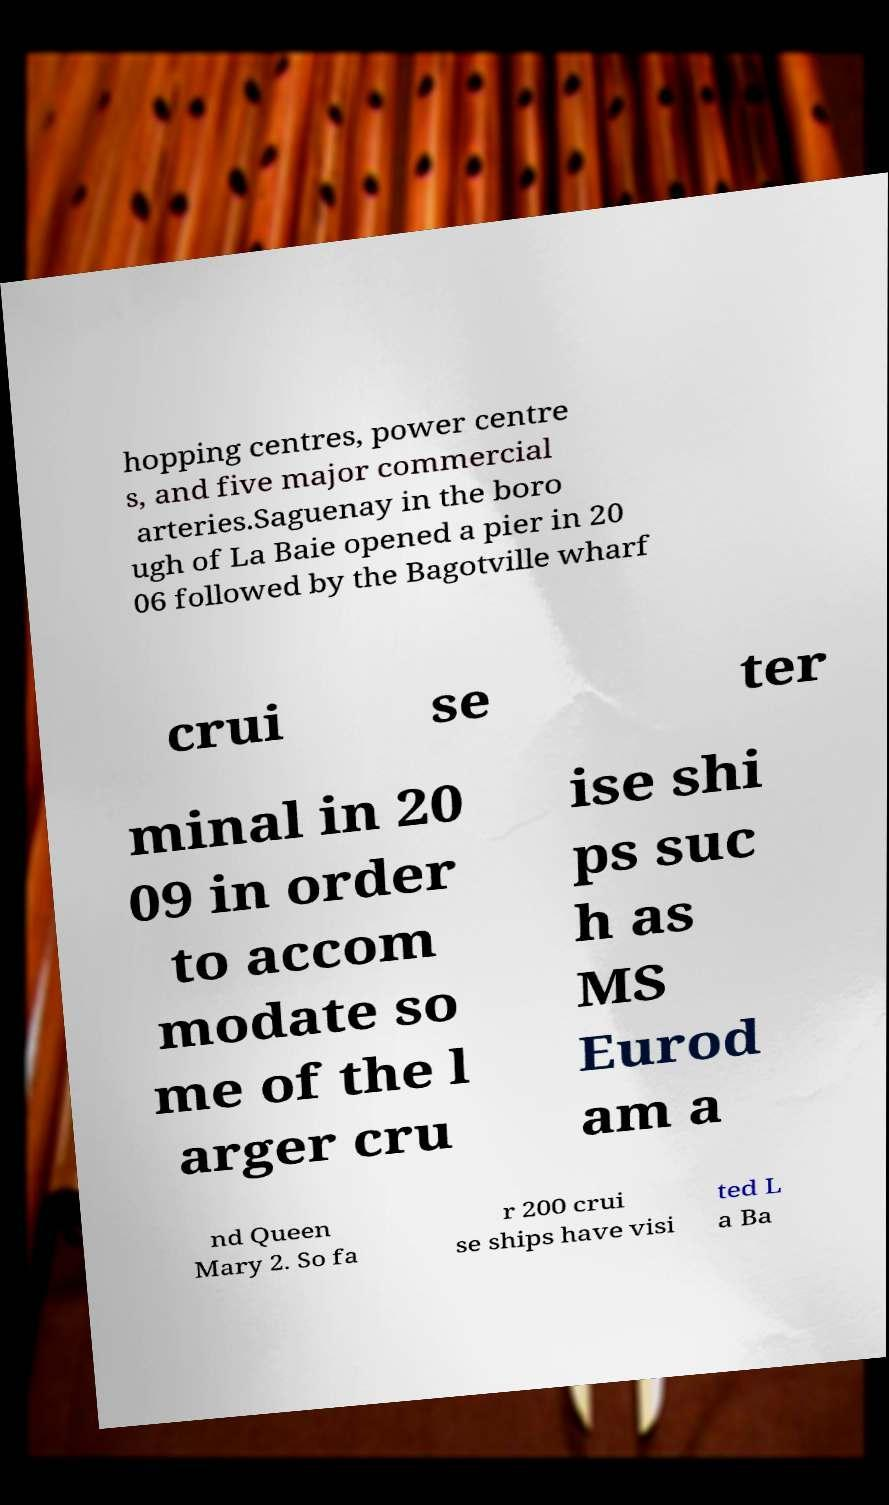For documentation purposes, I need the text within this image transcribed. Could you provide that? hopping centres, power centre s, and five major commercial arteries.Saguenay in the boro ugh of La Baie opened a pier in 20 06 followed by the Bagotville wharf crui se ter minal in 20 09 in order to accom modate so me of the l arger cru ise shi ps suc h as MS Eurod am a nd Queen Mary 2. So fa r 200 crui se ships have visi ted L a Ba 